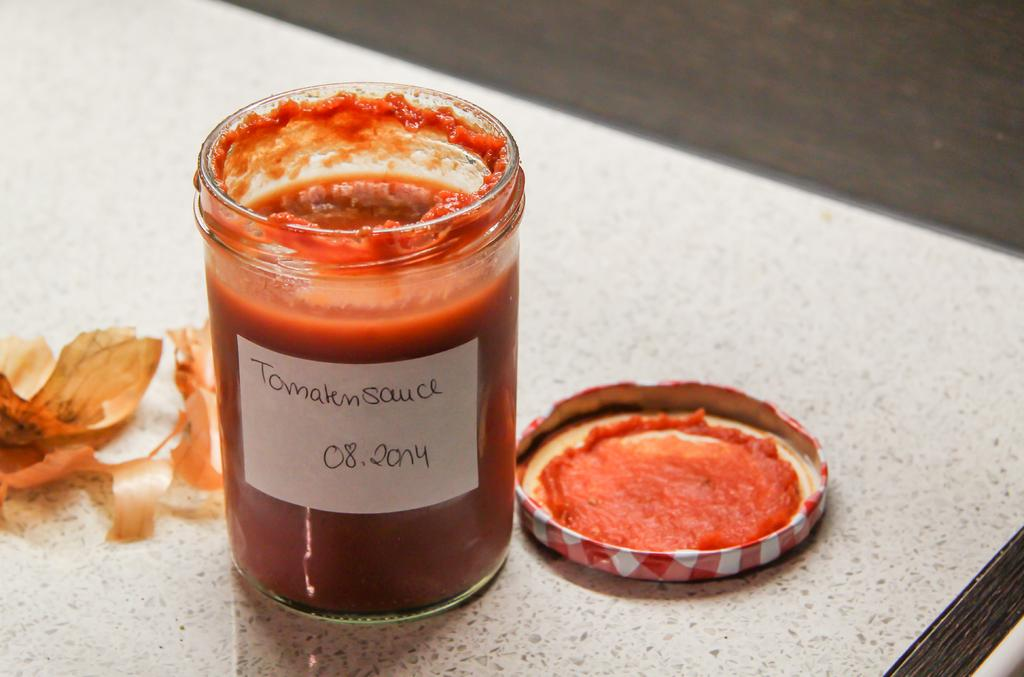What is inside the jar that is visible in the image? There is a jar with cream in the image. How is the jar sealed? The jar has a cap. What is placed on top of the cream in the jar? There is a flower on the surface of the cream. On what surface is the jar placed? The surface appears to be a table. What is the color of the table? The table is white in color. What additional information is provided on the jar? There is a sticker with text on the jar. How many flies are buzzing around the skin in the image? There is no skin or flies present in the image. What type of parcel is being delivered to the table in the image? There is no parcel being delivered in the image; it only features a jar with cream, a flower, and a table. 